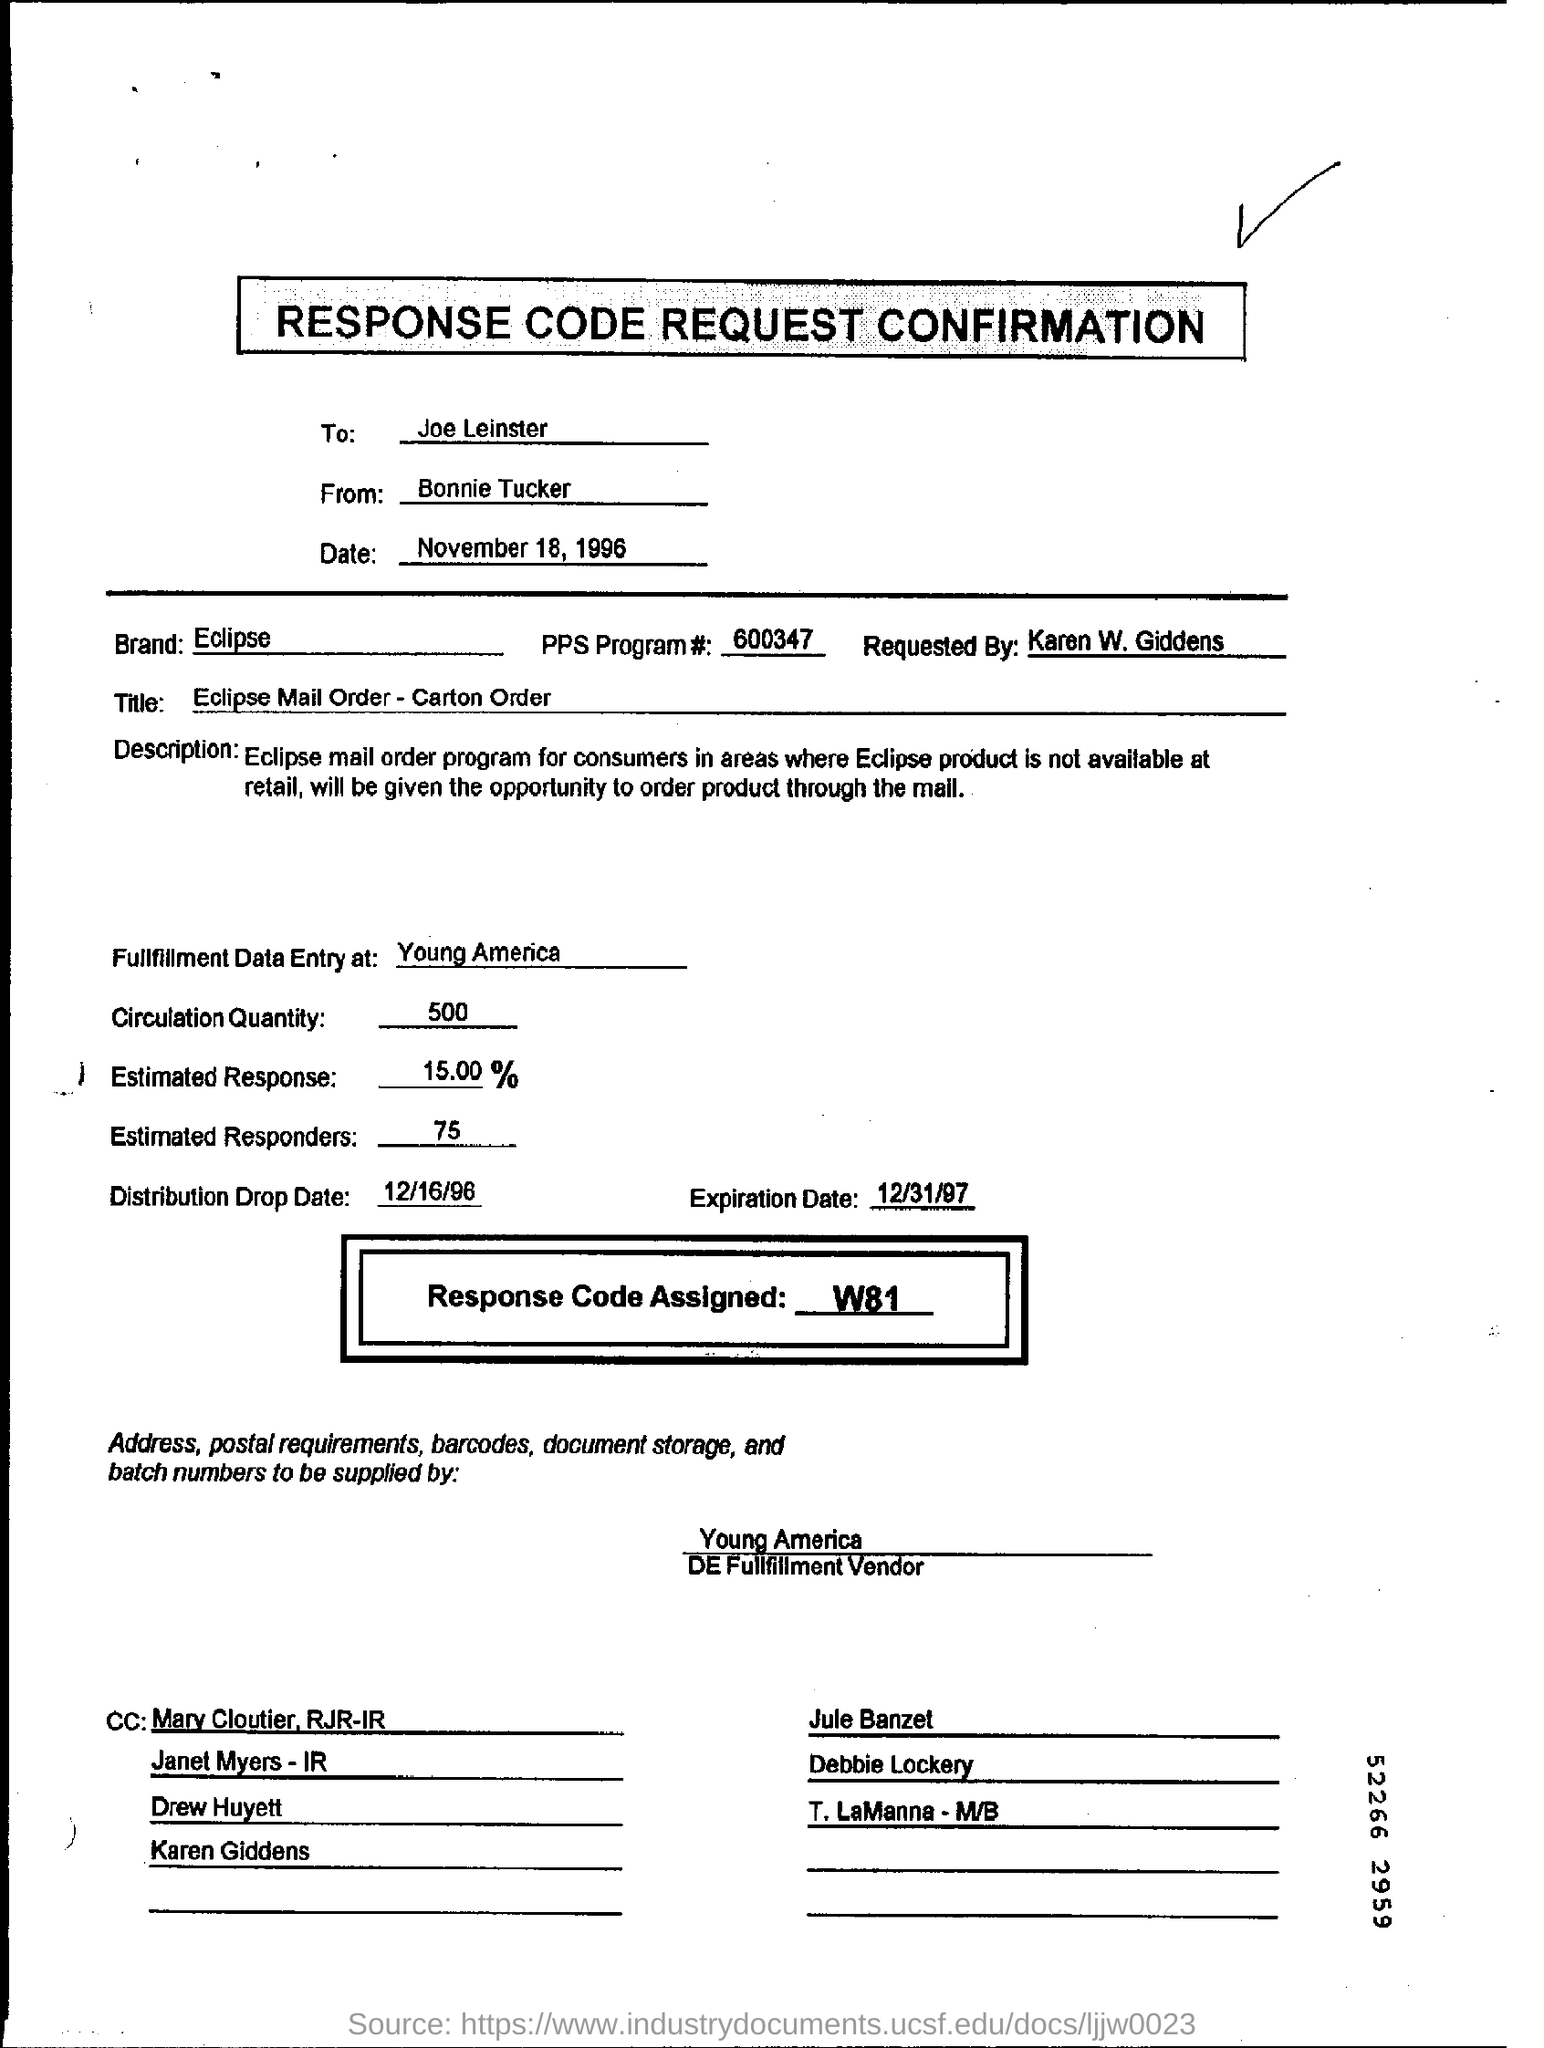What is the Response Code Assigned ?
Ensure brevity in your answer.  W81. What is the Circulation Quantity ?
Your answer should be very brief. 500. Which is the Distribution Drop Date ?
Your answer should be compact. 12/16/96. 